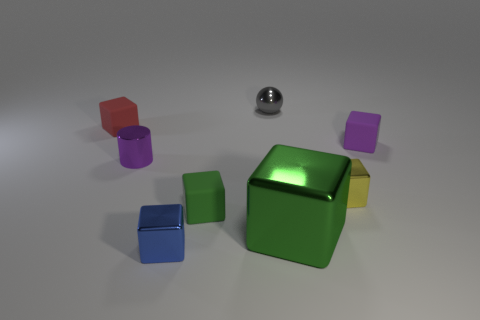How many objects are there, and could you describe their arrangement? There are six objects in total, arranged somewhat haphazardly on a flat surface. They seem to be spaced apart without any specific pattern, with the green cube being centrally positioned and the others scattered around it. 